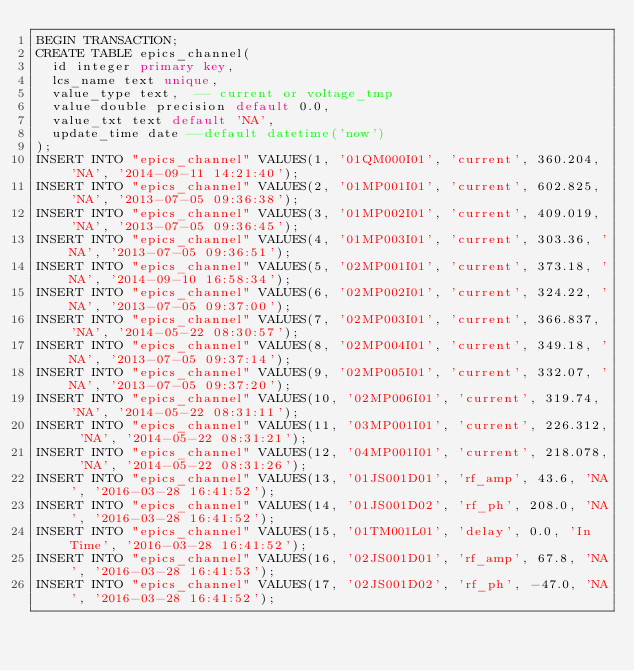<code> <loc_0><loc_0><loc_500><loc_500><_SQL_>BEGIN TRANSACTION;
CREATE TABLE epics_channel(
  id integer primary key,
  lcs_name text unique,
  value_type text,  -- current or voltage_tmp
  value double precision default 0.0,
  value_txt text default 'NA',
  update_time date --default datetime('now')
);
INSERT INTO "epics_channel" VALUES(1, '01QM000I01', 'current', 360.204, 'NA', '2014-09-11 14:21:40');
INSERT INTO "epics_channel" VALUES(2, '01MP001I01', 'current', 602.825, 'NA', '2013-07-05 09:36:38');
INSERT INTO "epics_channel" VALUES(3, '01MP002I01', 'current', 409.019, 'NA', '2013-07-05 09:36:45');
INSERT INTO "epics_channel" VALUES(4, '01MP003I01', 'current', 303.36, 'NA', '2013-07-05 09:36:51');
INSERT INTO "epics_channel" VALUES(5, '02MP001I01', 'current', 373.18, 'NA', '2014-09-10 16:58:34');
INSERT INTO "epics_channel" VALUES(6, '02MP002I01', 'current', 324.22, 'NA', '2013-07-05 09:37:00');
INSERT INTO "epics_channel" VALUES(7, '02MP003I01', 'current', 366.837, 'NA', '2014-05-22 08:30:57');
INSERT INTO "epics_channel" VALUES(8, '02MP004I01', 'current', 349.18, 'NA', '2013-07-05 09:37:14');
INSERT INTO "epics_channel" VALUES(9, '02MP005I01', 'current', 332.07, 'NA', '2013-07-05 09:37:20');
INSERT INTO "epics_channel" VALUES(10, '02MP006I01', 'current', 319.74, 'NA', '2014-05-22 08:31:11');
INSERT INTO "epics_channel" VALUES(11, '03MP001I01', 'current', 226.312, 'NA', '2014-05-22 08:31:21');
INSERT INTO "epics_channel" VALUES(12, '04MP001I01', 'current', 218.078, 'NA', '2014-05-22 08:31:26');
INSERT INTO "epics_channel" VALUES(13, '01JS001D01', 'rf_amp', 43.6, 'NA', '2016-03-28 16:41:52');
INSERT INTO "epics_channel" VALUES(14, '01JS001D02', 'rf_ph', 208.0, 'NA', '2016-03-28 16:41:52');
INSERT INTO "epics_channel" VALUES(15, '01TM001L01', 'delay', 0.0, 'In Time', '2016-03-28 16:41:52');
INSERT INTO "epics_channel" VALUES(16, '02JS001D01', 'rf_amp', 67.8, 'NA', '2016-03-28 16:41:53');
INSERT INTO "epics_channel" VALUES(17, '02JS001D02', 'rf_ph', -47.0, 'NA', '2016-03-28 16:41:52');</code> 